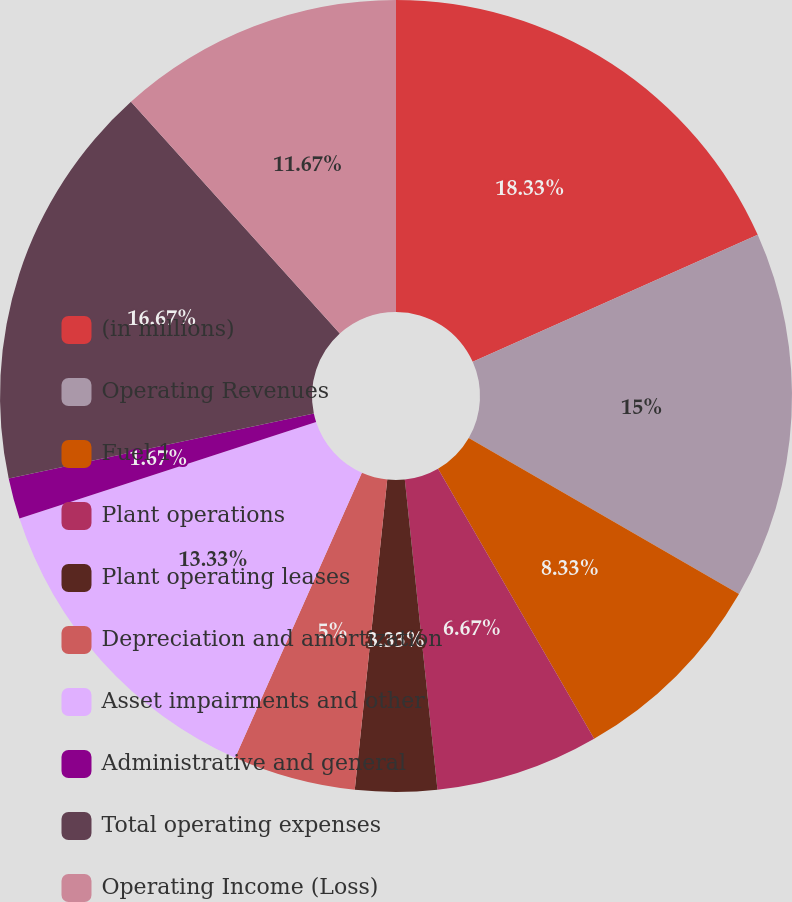<chart> <loc_0><loc_0><loc_500><loc_500><pie_chart><fcel>(in millions)<fcel>Operating Revenues<fcel>Fuel 1<fcel>Plant operations<fcel>Plant operating leases<fcel>Depreciation and amortization<fcel>Asset impairments and other<fcel>Administrative and general<fcel>Total operating expenses<fcel>Operating Income (Loss)<nl><fcel>18.33%<fcel>15.0%<fcel>8.33%<fcel>6.67%<fcel>3.33%<fcel>5.0%<fcel>13.33%<fcel>1.67%<fcel>16.67%<fcel>11.67%<nl></chart> 